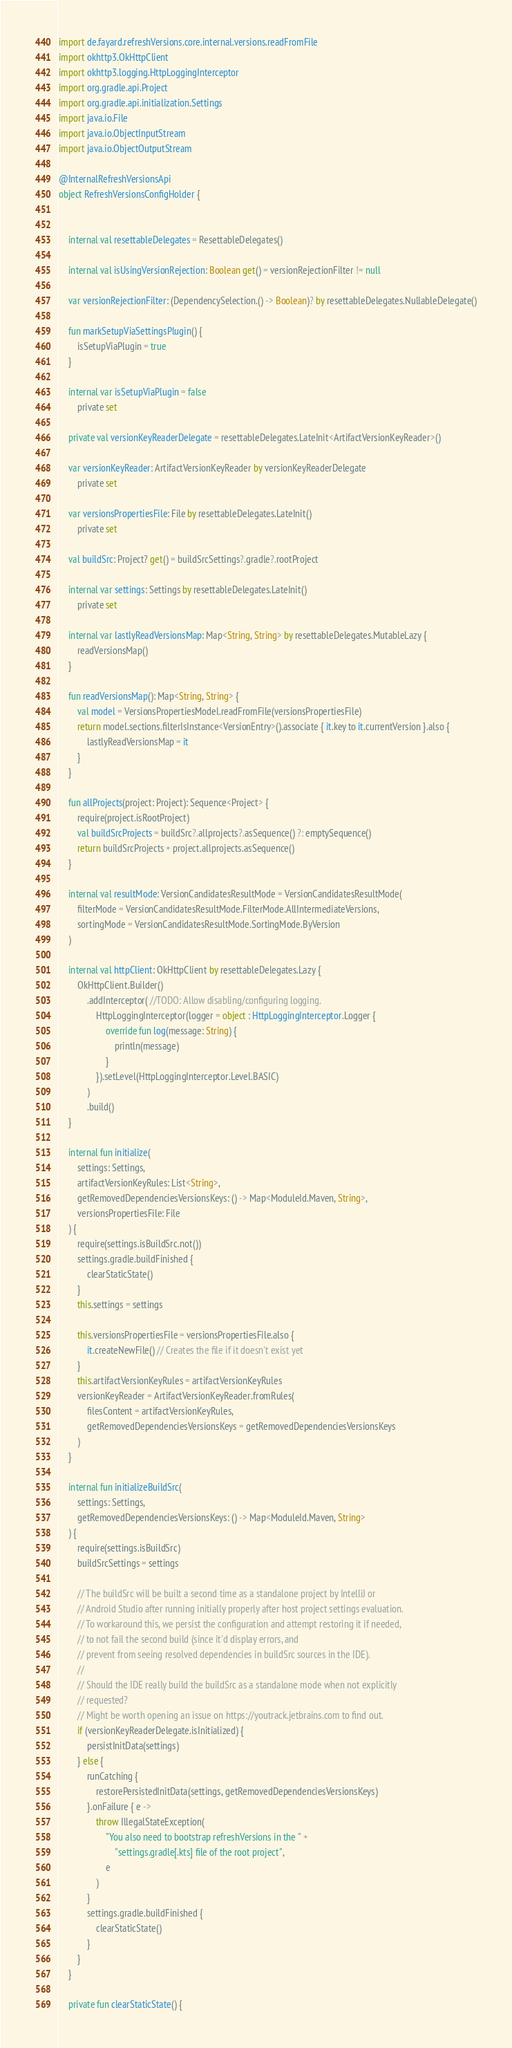<code> <loc_0><loc_0><loc_500><loc_500><_Kotlin_>import de.fayard.refreshVersions.core.internal.versions.readFromFile
import okhttp3.OkHttpClient
import okhttp3.logging.HttpLoggingInterceptor
import org.gradle.api.Project
import org.gradle.api.initialization.Settings
import java.io.File
import java.io.ObjectInputStream
import java.io.ObjectOutputStream

@InternalRefreshVersionsApi
object RefreshVersionsConfigHolder {


    internal val resettableDelegates = ResettableDelegates()

    internal val isUsingVersionRejection: Boolean get() = versionRejectionFilter != null

    var versionRejectionFilter: (DependencySelection.() -> Boolean)? by resettableDelegates.NullableDelegate()

    fun markSetupViaSettingsPlugin() {
        isSetupViaPlugin = true
    }

    internal var isSetupViaPlugin = false
        private set

    private val versionKeyReaderDelegate = resettableDelegates.LateInit<ArtifactVersionKeyReader>()

    var versionKeyReader: ArtifactVersionKeyReader by versionKeyReaderDelegate
        private set

    var versionsPropertiesFile: File by resettableDelegates.LateInit()
        private set

    val buildSrc: Project? get() = buildSrcSettings?.gradle?.rootProject

    internal var settings: Settings by resettableDelegates.LateInit()
        private set

    internal var lastlyReadVersionsMap: Map<String, String> by resettableDelegates.MutableLazy {
        readVersionsMap()
    }

    fun readVersionsMap(): Map<String, String> {
        val model = VersionsPropertiesModel.readFromFile(versionsPropertiesFile)
        return model.sections.filterIsInstance<VersionEntry>().associate { it.key to it.currentVersion }.also {
            lastlyReadVersionsMap = it
        }
    }

    fun allProjects(project: Project): Sequence<Project> {
        require(project.isRootProject)
        val buildSrcProjects = buildSrc?.allprojects?.asSequence() ?: emptySequence()
        return buildSrcProjects + project.allprojects.asSequence()
    }

    internal val resultMode: VersionCandidatesResultMode = VersionCandidatesResultMode(
        filterMode = VersionCandidatesResultMode.FilterMode.AllIntermediateVersions,
        sortingMode = VersionCandidatesResultMode.SortingMode.ByVersion
    )

    internal val httpClient: OkHttpClient by resettableDelegates.Lazy {
        OkHttpClient.Builder()
            .addInterceptor( //TODO: Allow disabling/configuring logging.
                HttpLoggingInterceptor(logger = object : HttpLoggingInterceptor.Logger {
                    override fun log(message: String) {
                        println(message)
                    }
                }).setLevel(HttpLoggingInterceptor.Level.BASIC)
            )
            .build()
    }

    internal fun initialize(
        settings: Settings,
        artifactVersionKeyRules: List<String>,
        getRemovedDependenciesVersionsKeys: () -> Map<ModuleId.Maven, String>,
        versionsPropertiesFile: File
    ) {
        require(settings.isBuildSrc.not())
        settings.gradle.buildFinished {
            clearStaticState()
        }
        this.settings = settings

        this.versionsPropertiesFile = versionsPropertiesFile.also {
            it.createNewFile() // Creates the file if it doesn't exist yet
        }
        this.artifactVersionKeyRules = artifactVersionKeyRules
        versionKeyReader = ArtifactVersionKeyReader.fromRules(
            filesContent = artifactVersionKeyRules,
            getRemovedDependenciesVersionsKeys = getRemovedDependenciesVersionsKeys
        )
    }

    internal fun initializeBuildSrc(
        settings: Settings,
        getRemovedDependenciesVersionsKeys: () -> Map<ModuleId.Maven, String>
    ) {
        require(settings.isBuildSrc)
        buildSrcSettings = settings

        // The buildSrc will be built a second time as a standalone project by IntelliJ or
        // Android Studio after running initially properly after host project settings evaluation.
        // To workaround this, we persist the configuration and attempt restoring it if needed,
        // to not fail the second build (since it'd display errors, and
        // prevent from seeing resolved dependencies in buildSrc sources in the IDE).
        //
        // Should the IDE really build the buildSrc as a standalone mode when not explicitly
        // requested?
        // Might be worth opening an issue on https://youtrack.jetbrains.com to find out.
        if (versionKeyReaderDelegate.isInitialized) {
            persistInitData(settings)
        } else {
            runCatching {
                restorePersistedInitData(settings, getRemovedDependenciesVersionsKeys)
            }.onFailure { e ->
                throw IllegalStateException(
                    "You also need to bootstrap refreshVersions in the " +
                        "settings.gradle[.kts] file of the root project",
                    e
                )
            }
            settings.gradle.buildFinished {
                clearStaticState()
            }
        }
    }

    private fun clearStaticState() {</code> 